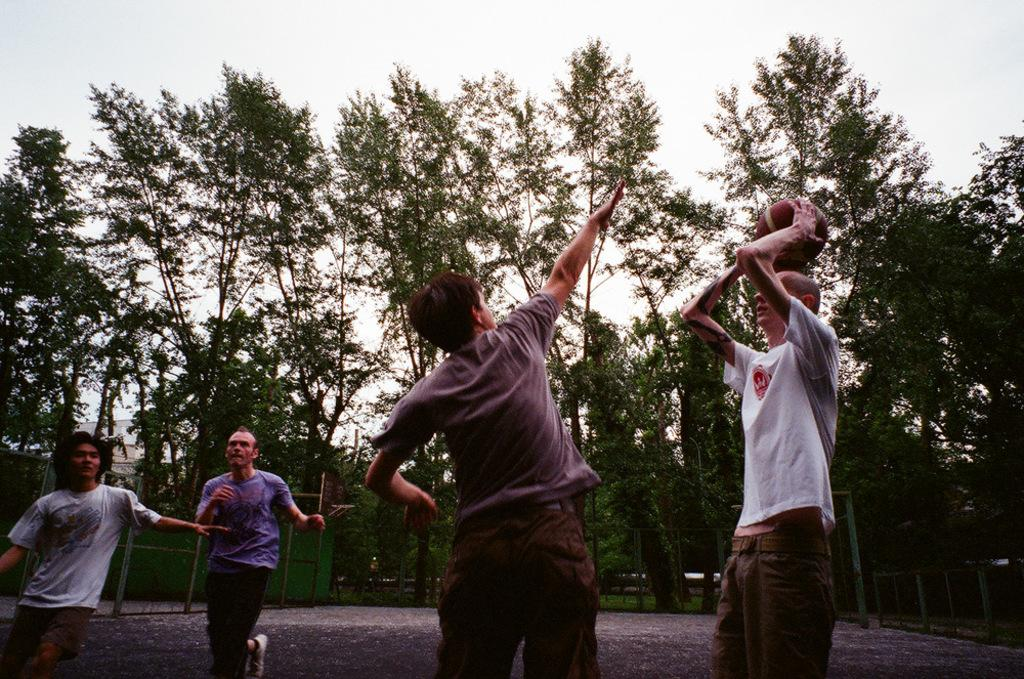What type of natural elements can be seen in the image? There are trees in the image. Can you describe the people in the image? There are people in the image. What kind of barrier is present in the image? There is a fence in the image. What object is visible on the ground in the image? There is a ball in the image. What is visible above the trees and fence in the image? The sky is visible in the image. What type of cracker is being used as a prop in the image? There is no cracker present in the image. Can you describe the boy playing with the ball in the image? There is no boy mentioned in the provided facts, so we cannot describe a boy playing with the ball. 